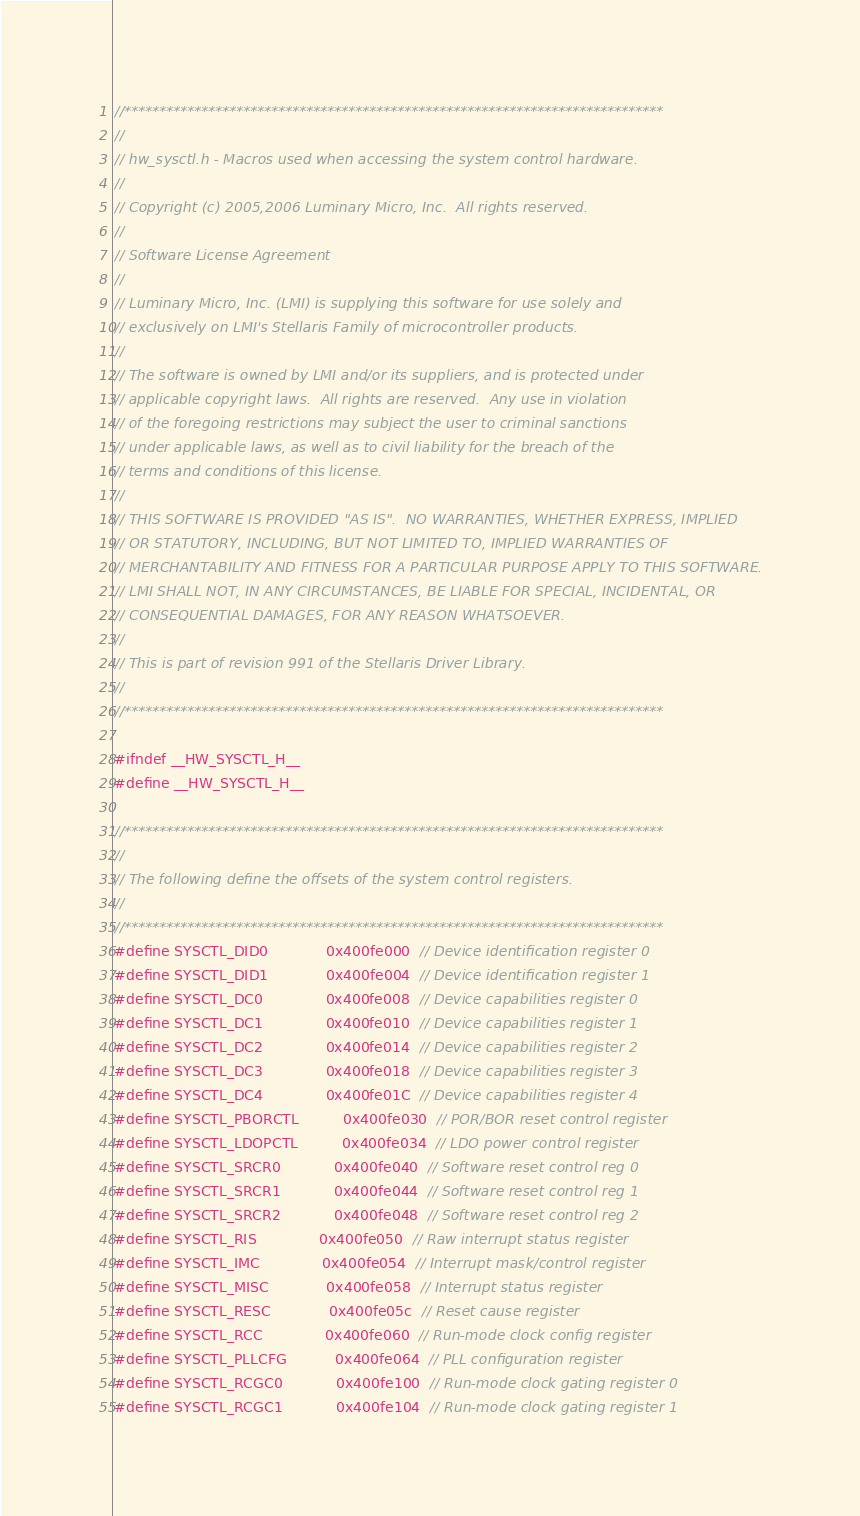<code> <loc_0><loc_0><loc_500><loc_500><_C_>//*****************************************************************************
//
// hw_sysctl.h - Macros used when accessing the system control hardware.
//
// Copyright (c) 2005,2006 Luminary Micro, Inc.  All rights reserved.
//
// Software License Agreement
//
// Luminary Micro, Inc. (LMI) is supplying this software for use solely and
// exclusively on LMI's Stellaris Family of microcontroller products.
//
// The software is owned by LMI and/or its suppliers, and is protected under
// applicable copyright laws.  All rights are reserved.  Any use in violation
// of the foregoing restrictions may subject the user to criminal sanctions
// under applicable laws, as well as to civil liability for the breach of the
// terms and conditions of this license.
//
// THIS SOFTWARE IS PROVIDED "AS IS".  NO WARRANTIES, WHETHER EXPRESS, IMPLIED
// OR STATUTORY, INCLUDING, BUT NOT LIMITED TO, IMPLIED WARRANTIES OF
// MERCHANTABILITY AND FITNESS FOR A PARTICULAR PURPOSE APPLY TO THIS SOFTWARE.
// LMI SHALL NOT, IN ANY CIRCUMSTANCES, BE LIABLE FOR SPECIAL, INCIDENTAL, OR
// CONSEQUENTIAL DAMAGES, FOR ANY REASON WHATSOEVER.
//
// This is part of revision 991 of the Stellaris Driver Library.
//
//*****************************************************************************

#ifndef __HW_SYSCTL_H__
#define __HW_SYSCTL_H__

//*****************************************************************************
//
// The following define the offsets of the system control registers.
//
//*****************************************************************************
#define SYSCTL_DID0             0x400fe000  // Device identification register 0
#define SYSCTL_DID1             0x400fe004  // Device identification register 1
#define SYSCTL_DC0              0x400fe008  // Device capabilities register 0
#define SYSCTL_DC1              0x400fe010  // Device capabilities register 1
#define SYSCTL_DC2              0x400fe014  // Device capabilities register 2
#define SYSCTL_DC3              0x400fe018  // Device capabilities register 3
#define SYSCTL_DC4              0x400fe01C  // Device capabilities register 4
#define SYSCTL_PBORCTL          0x400fe030  // POR/BOR reset control register
#define SYSCTL_LDOPCTL          0x400fe034  // LDO power control register
#define SYSCTL_SRCR0            0x400fe040  // Software reset control reg 0
#define SYSCTL_SRCR1            0x400fe044  // Software reset control reg 1
#define SYSCTL_SRCR2            0x400fe048  // Software reset control reg 2
#define SYSCTL_RIS              0x400fe050  // Raw interrupt status register
#define SYSCTL_IMC              0x400fe054  // Interrupt mask/control register
#define SYSCTL_MISC             0x400fe058  // Interrupt status register
#define SYSCTL_RESC             0x400fe05c  // Reset cause register
#define SYSCTL_RCC              0x400fe060  // Run-mode clock config register
#define SYSCTL_PLLCFG           0x400fe064  // PLL configuration register
#define SYSCTL_RCGC0            0x400fe100  // Run-mode clock gating register 0
#define SYSCTL_RCGC1            0x400fe104  // Run-mode clock gating register 1</code> 